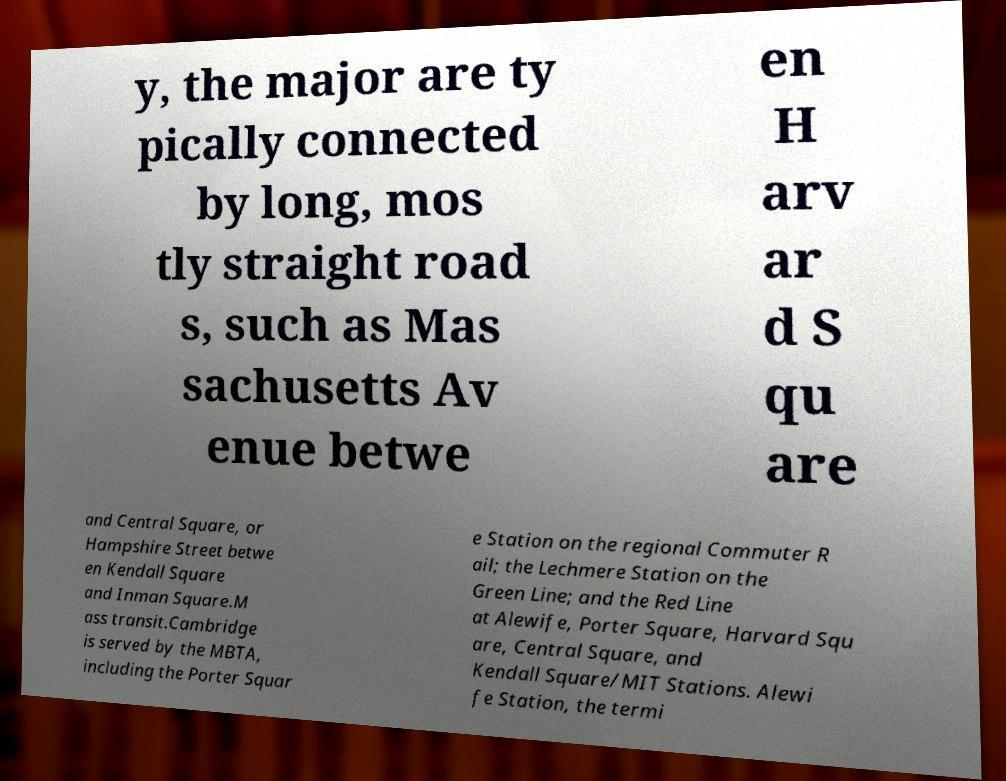Can you read and provide the text displayed in the image?This photo seems to have some interesting text. Can you extract and type it out for me? y, the major are ty pically connected by long, mos tly straight road s, such as Mas sachusetts Av enue betwe en H arv ar d S qu are and Central Square, or Hampshire Street betwe en Kendall Square and Inman Square.M ass transit.Cambridge is served by the MBTA, including the Porter Squar e Station on the regional Commuter R ail; the Lechmere Station on the Green Line; and the Red Line at Alewife, Porter Square, Harvard Squ are, Central Square, and Kendall Square/MIT Stations. Alewi fe Station, the termi 